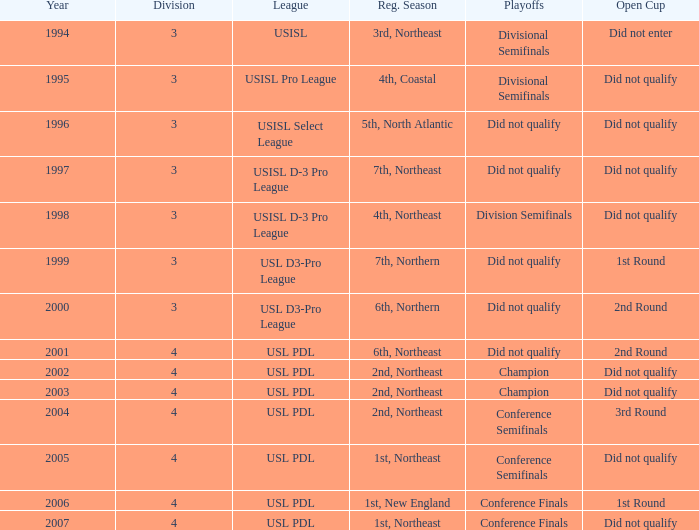Could you parse the entire table as a dict? {'header': ['Year', 'Division', 'League', 'Reg. Season', 'Playoffs', 'Open Cup'], 'rows': [['1994', '3', 'USISL', '3rd, Northeast', 'Divisional Semifinals', 'Did not enter'], ['1995', '3', 'USISL Pro League', '4th, Coastal', 'Divisional Semifinals', 'Did not qualify'], ['1996', '3', 'USISL Select League', '5th, North Atlantic', 'Did not qualify', 'Did not qualify'], ['1997', '3', 'USISL D-3 Pro League', '7th, Northeast', 'Did not qualify', 'Did not qualify'], ['1998', '3', 'USISL D-3 Pro League', '4th, Northeast', 'Division Semifinals', 'Did not qualify'], ['1999', '3', 'USL D3-Pro League', '7th, Northern', 'Did not qualify', '1st Round'], ['2000', '3', 'USL D3-Pro League', '6th, Northern', 'Did not qualify', '2nd Round'], ['2001', '4', 'USL PDL', '6th, Northeast', 'Did not qualify', '2nd Round'], ['2002', '4', 'USL PDL', '2nd, Northeast', 'Champion', 'Did not qualify'], ['2003', '4', 'USL PDL', '2nd, Northeast', 'Champion', 'Did not qualify'], ['2004', '4', 'USL PDL', '2nd, Northeast', 'Conference Semifinals', '3rd Round'], ['2005', '4', 'USL PDL', '1st, Northeast', 'Conference Semifinals', 'Did not qualify'], ['2006', '4', 'USL PDL', '1st, New England', 'Conference Finals', '1st Round'], ['2007', '4', 'USL PDL', '1st, Northeast', 'Conference Finals', 'Did not qualify']]} Specify the count of playoffs in the 3rd round. 1.0. 